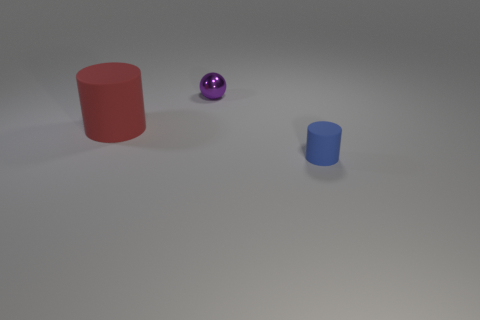Is there any other thing that is the same size as the red thing?
Your answer should be compact. No. How many tiny things are matte objects or brown rubber cylinders?
Provide a short and direct response. 1. How many purple spheres are the same material as the red cylinder?
Provide a short and direct response. 0. What is the size of the cylinder in front of the big red matte object?
Offer a terse response. Small. What is the shape of the rubber thing to the left of the object that is on the right side of the metallic sphere?
Give a very brief answer. Cylinder. There is a cylinder behind the small blue object that is on the right side of the small purple sphere; what number of red things are in front of it?
Ensure brevity in your answer.  0. Is the number of red cylinders on the right side of the large rubber cylinder less than the number of big brown rubber blocks?
Your answer should be compact. No. Are there any other things that have the same shape as the metallic thing?
Your response must be concise. No. What is the shape of the rubber object that is on the right side of the small purple sphere?
Your response must be concise. Cylinder. There is a rubber object left of the matte cylinder that is in front of the rubber cylinder on the left side of the blue thing; what shape is it?
Make the answer very short. Cylinder. 